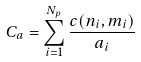<formula> <loc_0><loc_0><loc_500><loc_500>C _ { a } = \sum _ { i = 1 } ^ { N _ { p } } \frac { c ( n _ { i } , m _ { i } ) } { a _ { i } }</formula> 